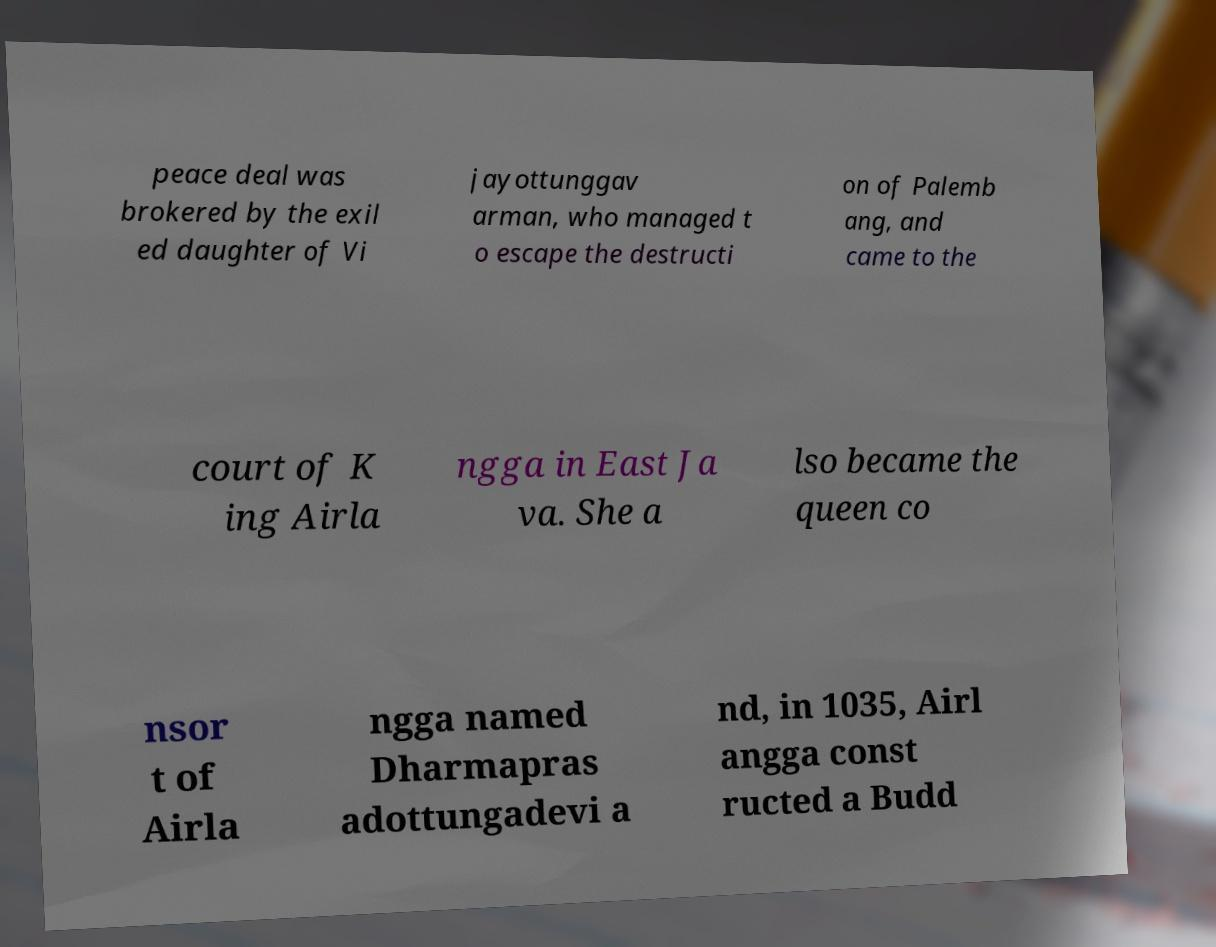What messages or text are displayed in this image? I need them in a readable, typed format. peace deal was brokered by the exil ed daughter of Vi jayottunggav arman, who managed t o escape the destructi on of Palemb ang, and came to the court of K ing Airla ngga in East Ja va. She a lso became the queen co nsor t of Airla ngga named Dharmapras adottungadevi a nd, in 1035, Airl angga const ructed a Budd 